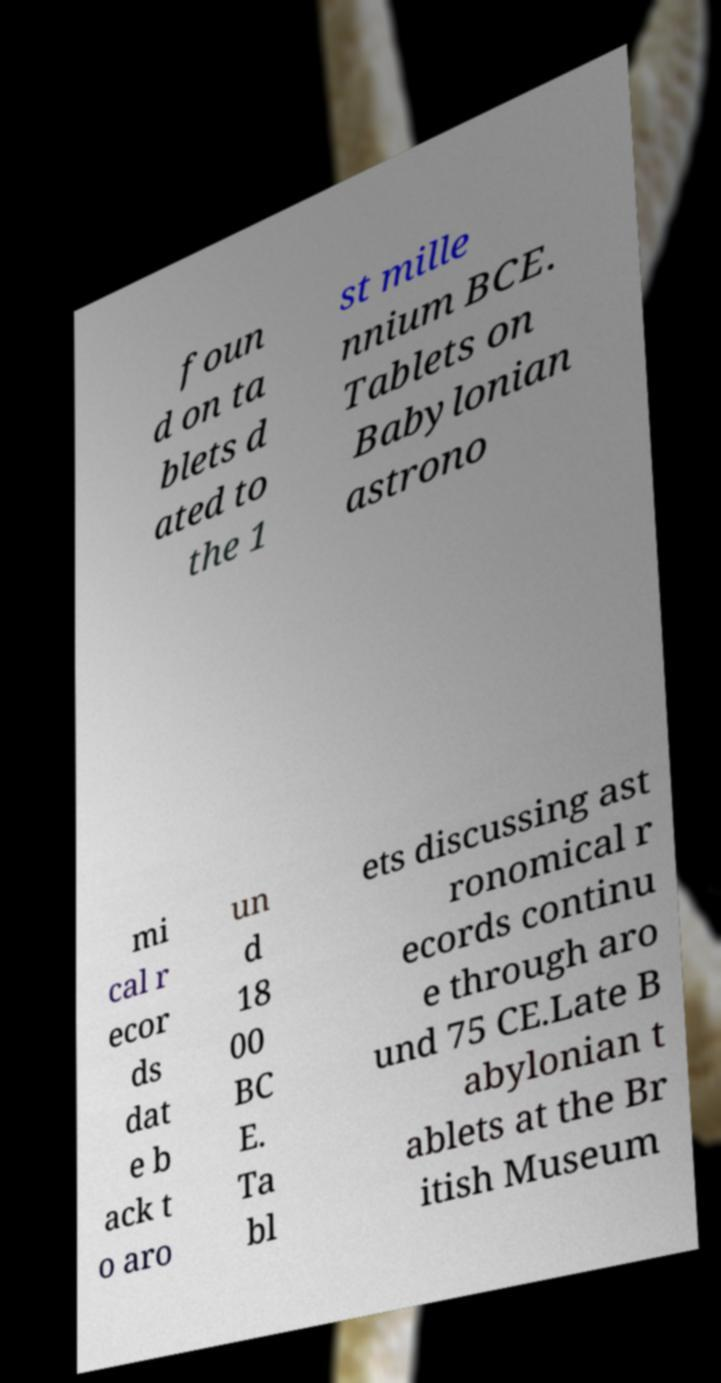There's text embedded in this image that I need extracted. Can you transcribe it verbatim? foun d on ta blets d ated to the 1 st mille nnium BCE. Tablets on Babylonian astrono mi cal r ecor ds dat e b ack t o aro un d 18 00 BC E. Ta bl ets discussing ast ronomical r ecords continu e through aro und 75 CE.Late B abylonian t ablets at the Br itish Museum 